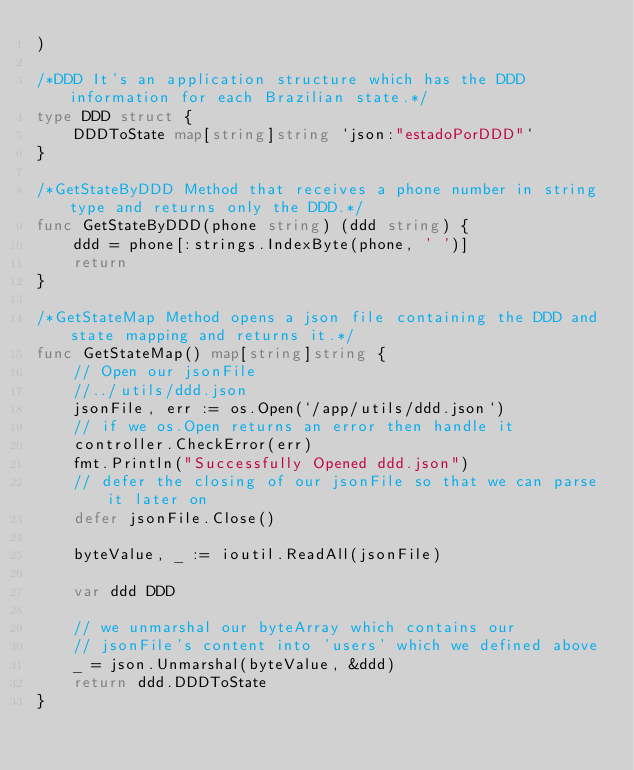Convert code to text. <code><loc_0><loc_0><loc_500><loc_500><_Go_>)

/*DDD It's an application structure which has the DDD information for each Brazilian state.*/
type DDD struct {
	DDDToState map[string]string `json:"estadoPorDDD"`
}

/*GetStateByDDD Method that receives a phone number in string type and returns only the DDD.*/
func GetStateByDDD(phone string) (ddd string) {
	ddd = phone[:strings.IndexByte(phone, ' ')]
	return
}

/*GetStateMap Method opens a json file containing the DDD and state mapping and returns it.*/
func GetStateMap() map[string]string {
	// Open our jsonFile
	//../utils/ddd.json
	jsonFile, err := os.Open(`/app/utils/ddd.json`)
	// if we os.Open returns an error then handle it
	controller.CheckError(err)
	fmt.Println("Successfully Opened ddd.json")
	// defer the closing of our jsonFile so that we can parse it later on
	defer jsonFile.Close()

	byteValue, _ := ioutil.ReadAll(jsonFile)

	var ddd DDD

	// we unmarshal our byteArray which contains our
	// jsonFile's content into 'users' which we defined above
	_ = json.Unmarshal(byteValue, &ddd)
	return ddd.DDDToState
}
</code> 